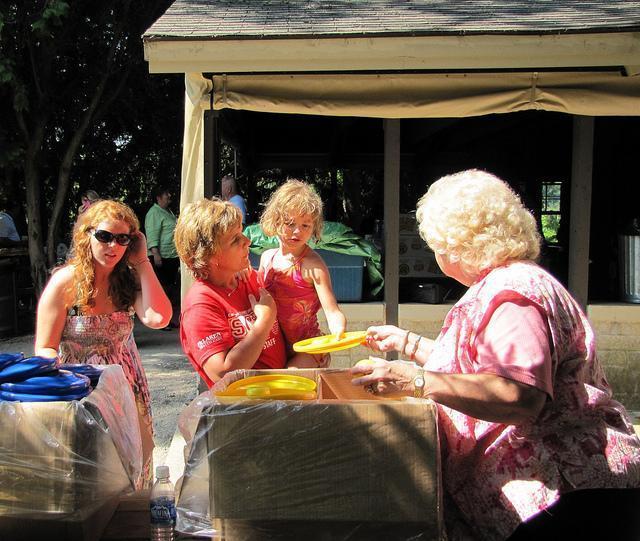How many people are wearing sunglasses?
Give a very brief answer. 1. How many people can you see?
Give a very brief answer. 5. 